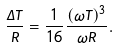Convert formula to latex. <formula><loc_0><loc_0><loc_500><loc_500>\frac { \Delta T } { R } = \frac { 1 } { 1 6 } \frac { ( \omega T ) ^ { 3 } } { \omega R } .</formula> 